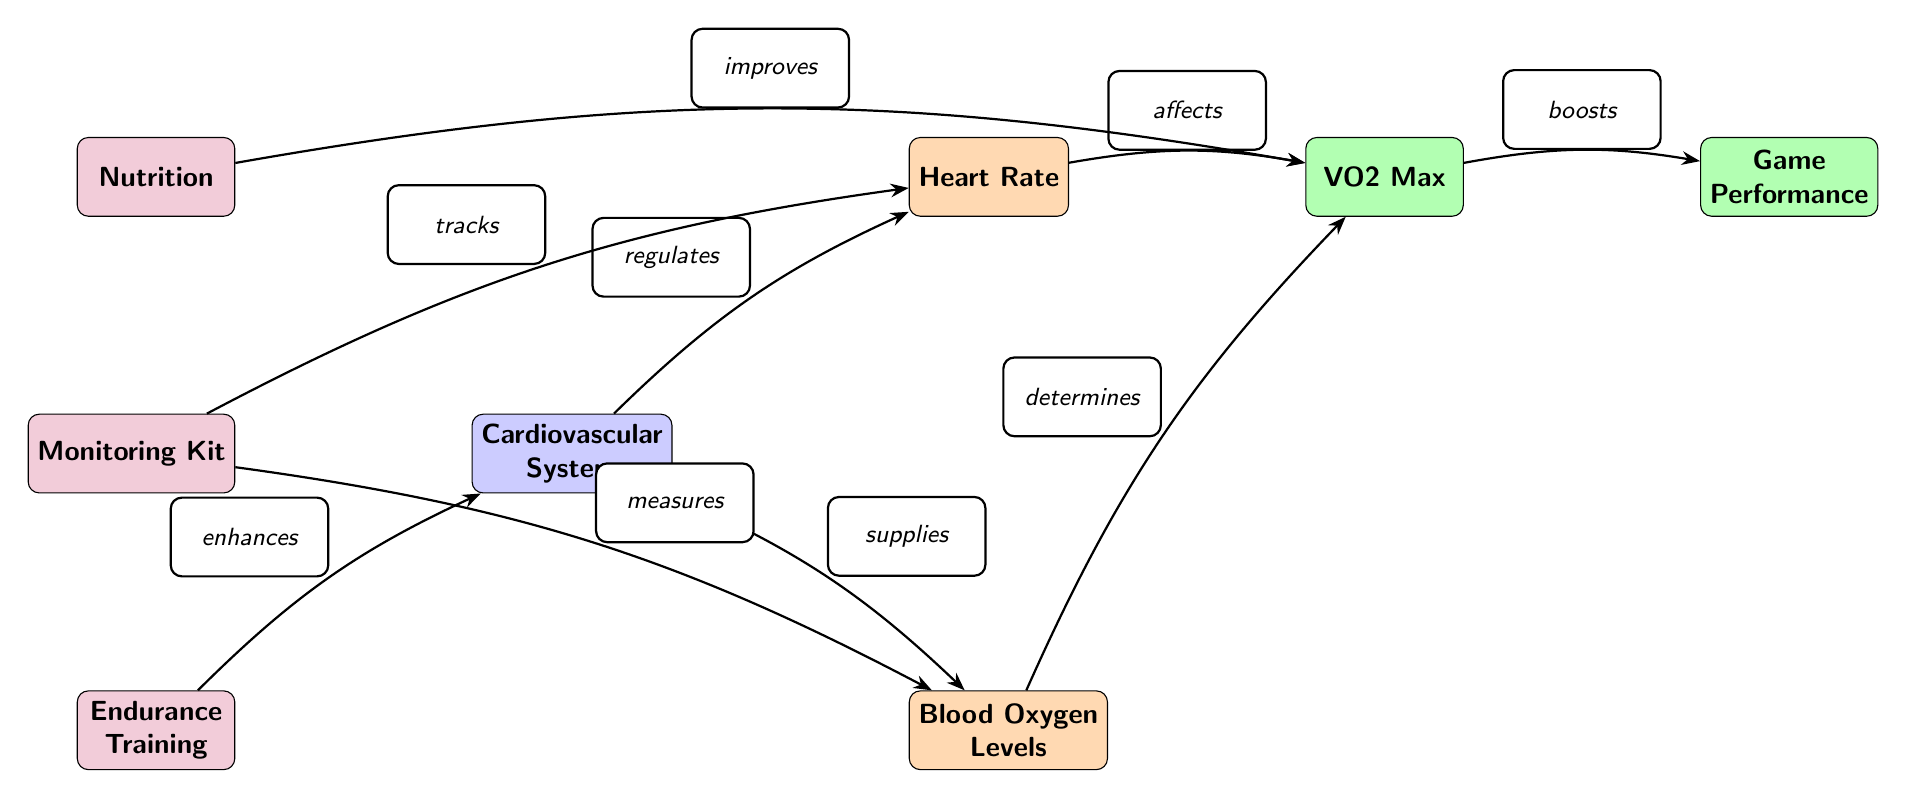What is the primary system depicted in the diagram? The diagram shows the cardiovascular system as the central node, indicating that this is the primary focus of the illustration.
Answer: Cardiovascular System How many performance factors are represented? The diagram features two performance factors, VO2 Max and Game Performance, indicating the impact of cardiovascular health on athletic performance.
Answer: 2 Which tool improves VO2 Max? The diagram indicates that Nutrition directly improves VO2 Max, suggesting that dietary choices can enhance cardiovascular performance.
Answer: Nutrition What does Heart Rate affect? According to the diagram, Heart Rate affects VO2 Max, signifying its role in determining aerobic capacity and endurance.
Answer: VO2 Max What does blood supply determine? The diagram establishes that Blood Oxygen Levels determine VO2 Max, illustrating the importance of oxygen delivery in endurance performance.
Answer: VO2 Max Which two elements are connected through endurance training? Endurance Training enhances the Cardiovascular System, demonstrating that consistent training can improve overall cardiovascular health.
Answer: Cardiovascular System What type of relationship exists between VO2 Max and Game Performance? The diagram illustrates that VO2 Max boosts Game Performance, indicating a positive relationship where higher aerobic capacity can lead to better performance in sports.
Answer: Boosts How do monitoring tools contribute to performance metrics? Monitoring Kit tracks Heart Rate and measures Blood Oxygen Levels, both of which provide crucial information for assessing cardiovascular fitness and performance metrics.
Answer: Tracks and measures What is the role of training in enhancing stamina? The diagram explicitly states that Endurance Training enhances the Cardiovascular System, which is essential for improving stamina necessary for optimal performance.
Answer: Enhances What regulates the Heart Rate in this diagram? The arrow labeled "regulates" shows that the Cardiovascular System is responsible for regulating Heart Rate, highlighting the interactive nature of body systems.
Answer: Cardiovascular System 